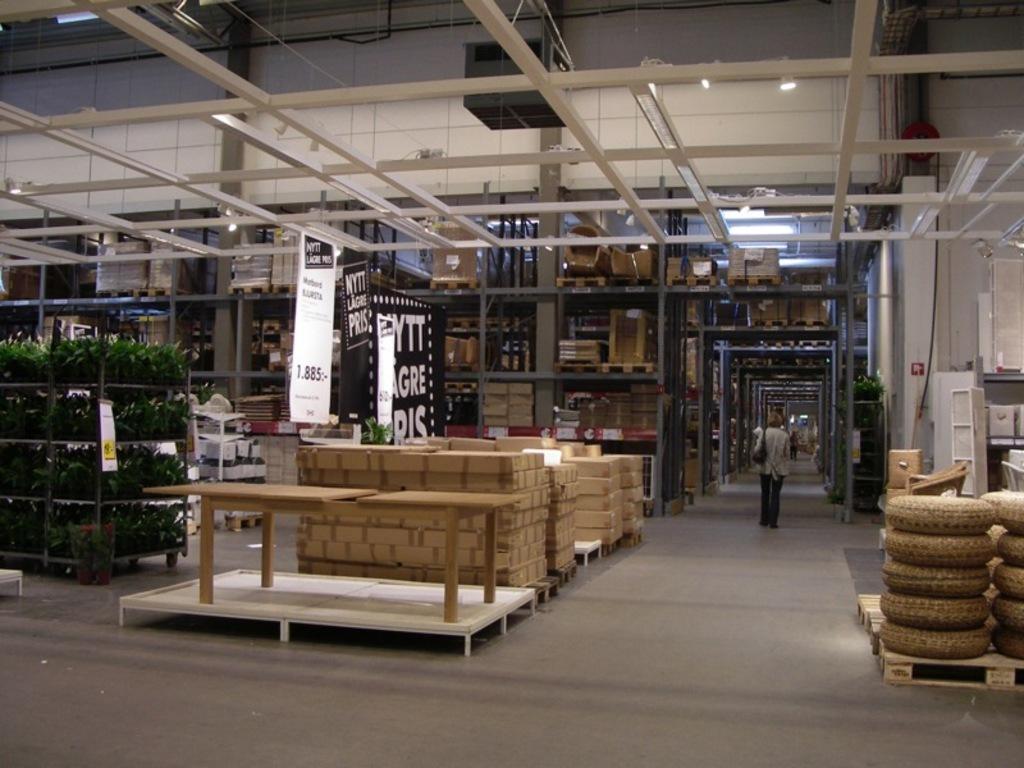Please provide a concise description of this image. In this picture there are plants in a rack on the left side of the image and there are boxes in the center of the image, there are other boxes in the background area of the image. 